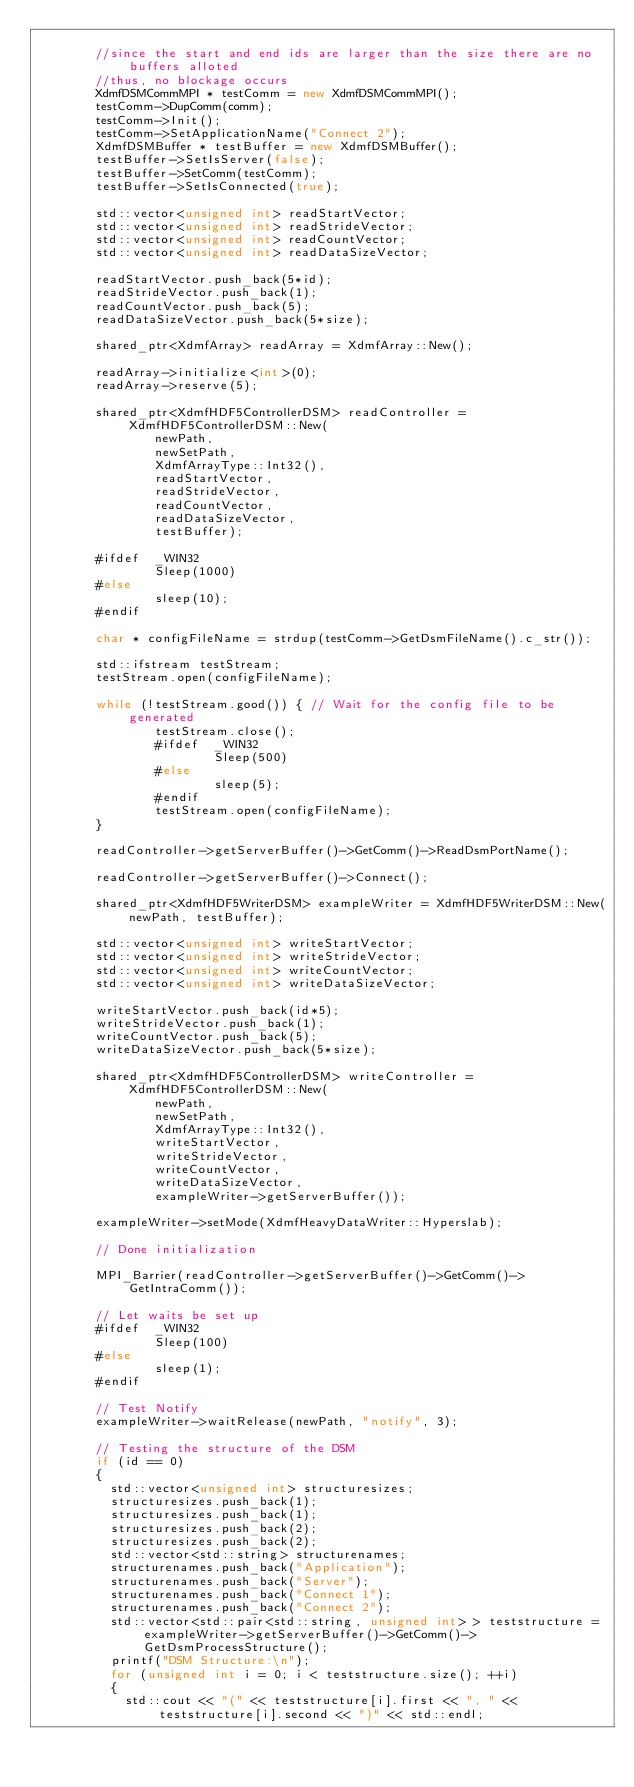Convert code to text. <code><loc_0><loc_0><loc_500><loc_500><_C++_>
        //since the start and end ids are larger than the size there are no buffers alloted
        //thus, no blockage occurs
        XdmfDSMCommMPI * testComm = new XdmfDSMCommMPI();
        testComm->DupComm(comm);
        testComm->Init();
        testComm->SetApplicationName("Connect 2");
        XdmfDSMBuffer * testBuffer = new XdmfDSMBuffer();
        testBuffer->SetIsServer(false);
        testBuffer->SetComm(testComm);
        testBuffer->SetIsConnected(true);

        std::vector<unsigned int> readStartVector;
        std::vector<unsigned int> readStrideVector;
        std::vector<unsigned int> readCountVector;
        std::vector<unsigned int> readDataSizeVector;

        readStartVector.push_back(5*id);
        readStrideVector.push_back(1);
        readCountVector.push_back(5);
        readDataSizeVector.push_back(5*size);

        shared_ptr<XdmfArray> readArray = XdmfArray::New();

        readArray->initialize<int>(0);
        readArray->reserve(5);

        shared_ptr<XdmfHDF5ControllerDSM> readController = XdmfHDF5ControllerDSM::New(
                newPath,
                newSetPath,
                XdmfArrayType::Int32(),
                readStartVector,
                readStrideVector,
                readCountVector,
                readDataSizeVector,
                testBuffer);

        #ifdef  _WIN32
                Sleep(1000)
        #else
                sleep(10);
        #endif

        char * configFileName = strdup(testComm->GetDsmFileName().c_str());

        std::ifstream testStream;
        testStream.open(configFileName);

        while (!testStream.good()) { // Wait for the config file to be generated
                testStream.close();
                #ifdef  _WIN32
                        Sleep(500)
                #else
                        sleep(5);
                #endif
                testStream.open(configFileName);
        }

        readController->getServerBuffer()->GetComm()->ReadDsmPortName();

        readController->getServerBuffer()->Connect();

        shared_ptr<XdmfHDF5WriterDSM> exampleWriter = XdmfHDF5WriterDSM::New(newPath, testBuffer);

        std::vector<unsigned int> writeStartVector;
        std::vector<unsigned int> writeStrideVector;
        std::vector<unsigned int> writeCountVector;
        std::vector<unsigned int> writeDataSizeVector;

        writeStartVector.push_back(id*5);
        writeStrideVector.push_back(1);
        writeCountVector.push_back(5);
        writeDataSizeVector.push_back(5*size);

        shared_ptr<XdmfHDF5ControllerDSM> writeController = XdmfHDF5ControllerDSM::New(
                newPath,
                newSetPath,
                XdmfArrayType::Int32(),
                writeStartVector,
                writeStrideVector,
                writeCountVector,
                writeDataSizeVector,
                exampleWriter->getServerBuffer());

        exampleWriter->setMode(XdmfHeavyDataWriter::Hyperslab);

        // Done initialization

        MPI_Barrier(readController->getServerBuffer()->GetComm()->GetIntraComm());

        // Let waits be set up
        #ifdef  _WIN32
                Sleep(100)
        #else
                sleep(1);
        #endif

        // Test Notify
        exampleWriter->waitRelease(newPath, "notify", 3);

        // Testing the structure of the DSM
        if (id == 0)
        {
          std::vector<unsigned int> structuresizes;
          structuresizes.push_back(1);
          structuresizes.push_back(1);
          structuresizes.push_back(2);
          structuresizes.push_back(2);
          std::vector<std::string> structurenames;
          structurenames.push_back("Application");
          structurenames.push_back("Server");
          structurenames.push_back("Connect 1");
          structurenames.push_back("Connect 2");
          std::vector<std::pair<std::string, unsigned int> > teststructure = exampleWriter->getServerBuffer()->GetComm()->GetDsmProcessStructure();
          printf("DSM Structure:\n");
          for (unsigned int i = 0; i < teststructure.size(); ++i)
          {
            std::cout << "(" << teststructure[i].first << ", " << teststructure[i].second << ")" << std::endl;</code> 